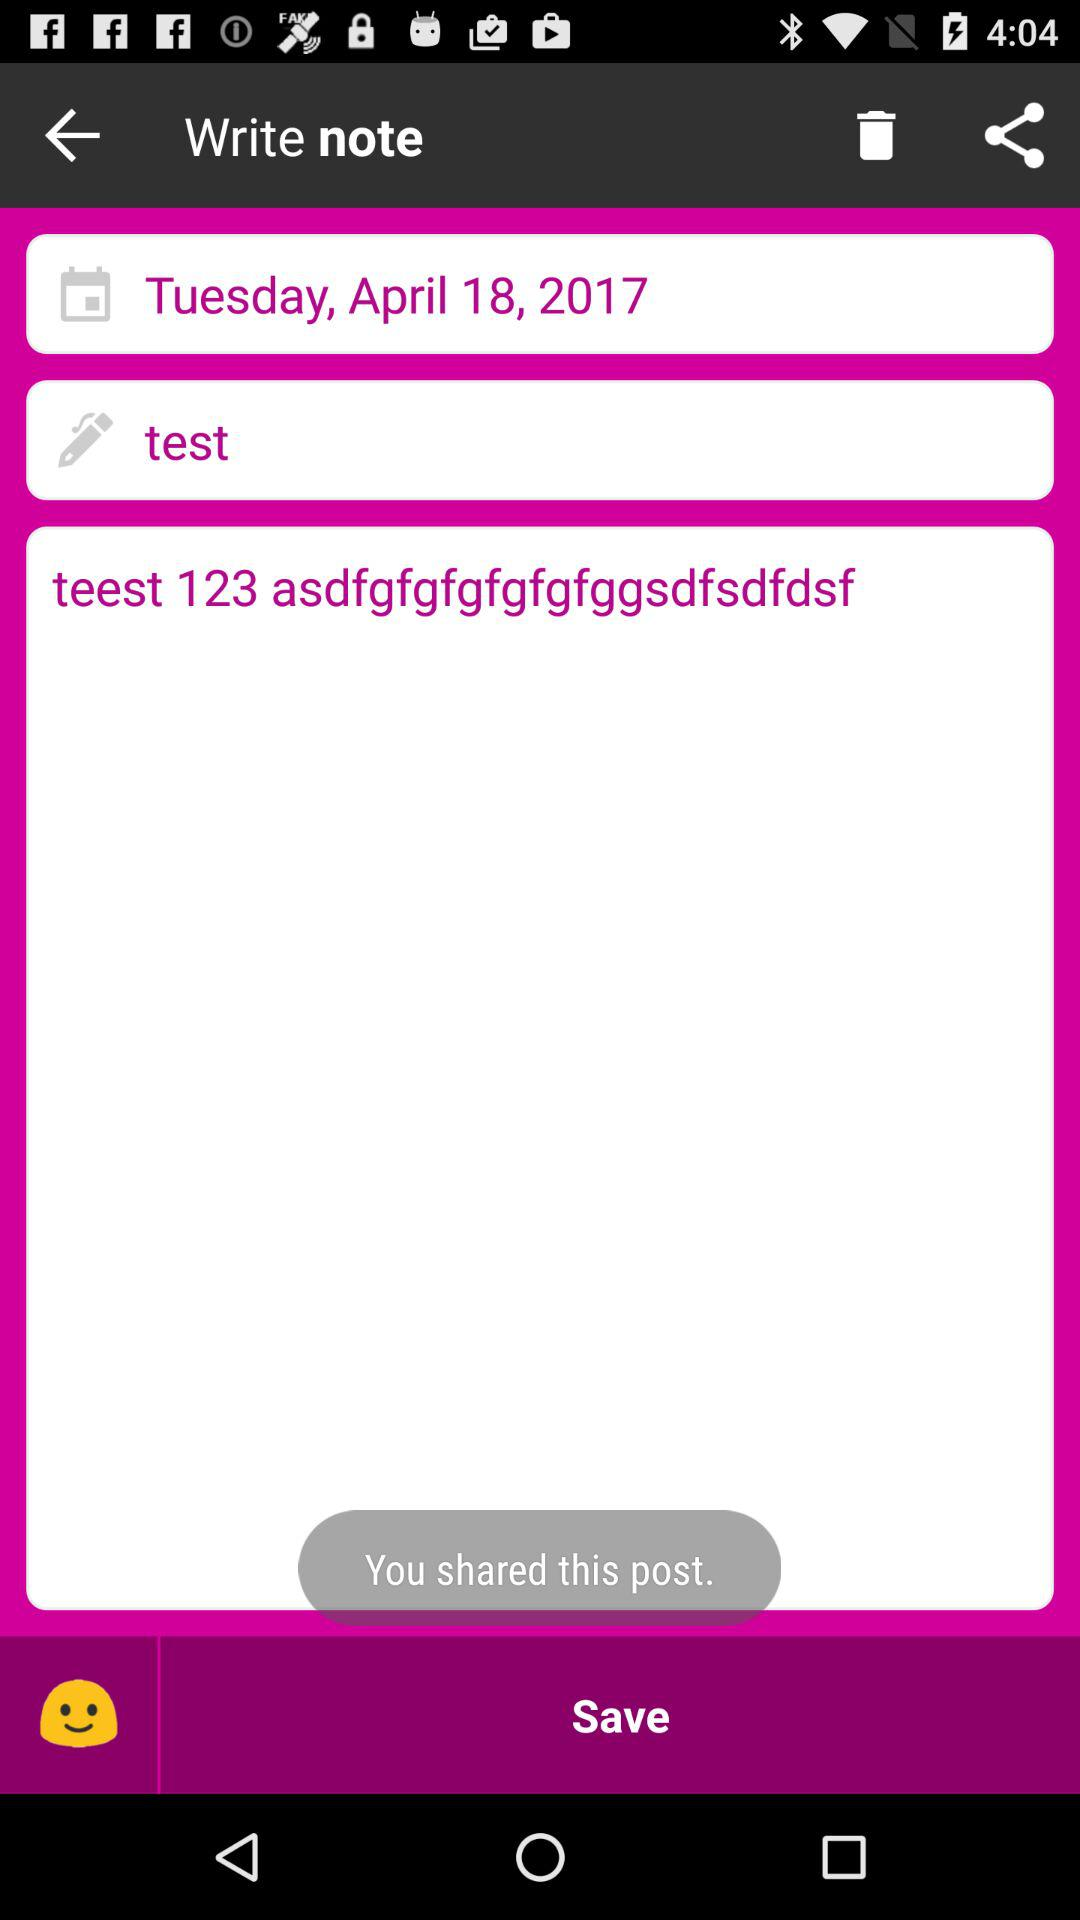What is the date? The date is Tuesday, April 18, 2017. 